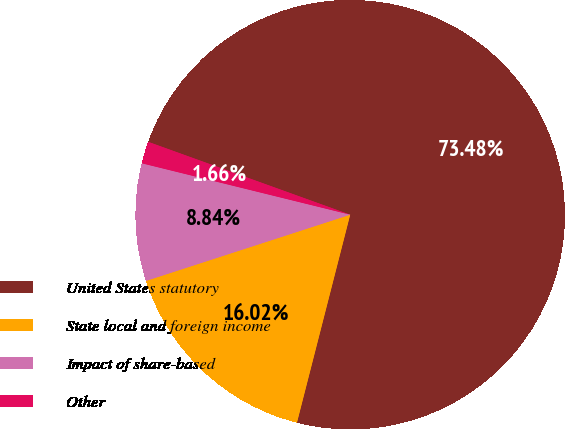<chart> <loc_0><loc_0><loc_500><loc_500><pie_chart><fcel>United States statutory<fcel>State local and foreign income<fcel>Impact of share-based<fcel>Other<nl><fcel>73.48%<fcel>16.02%<fcel>8.84%<fcel>1.66%<nl></chart> 